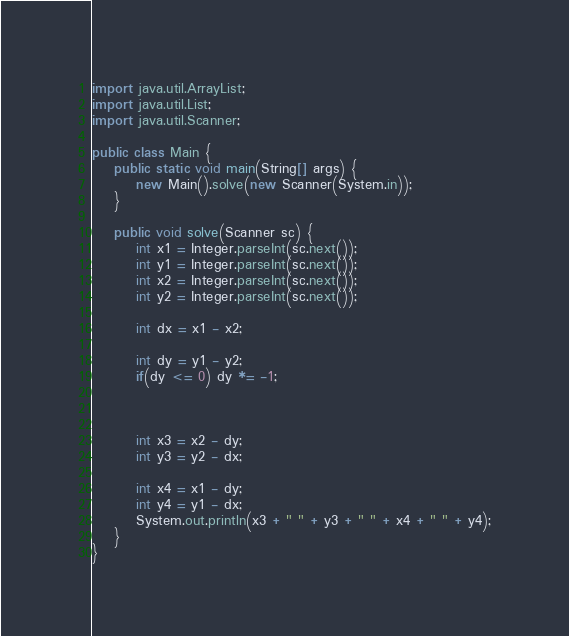Convert code to text. <code><loc_0><loc_0><loc_500><loc_500><_Java_>import java.util.ArrayList;
import java.util.List;
import java.util.Scanner;

public class Main {
	public static void main(String[] args) {
		new Main().solve(new Scanner(System.in));
	}
	
	public void solve(Scanner sc) {
		int x1 = Integer.parseInt(sc.next());
		int y1 = Integer.parseInt(sc.next());
		int x2 = Integer.parseInt(sc.next());
		int y2 = Integer.parseInt(sc.next());
		
		int dx = x1 - x2;
		
		int dy = y1 - y2;
		if(dy <= 0) dy *= -1;
		
		
		
		int x3 = x2 - dy;
		int y3 = y2 - dx;
		
		int x4 = x1 - dy;
		int y4 = y1 - dx;
		System.out.println(x3 + " " + y3 + " " + x4 + " " + y4);
	}
}
</code> 